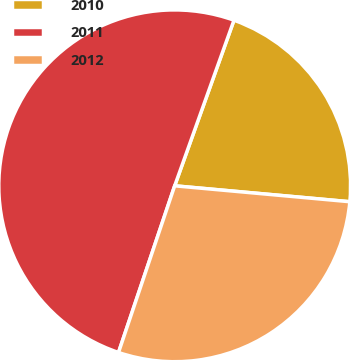Convert chart. <chart><loc_0><loc_0><loc_500><loc_500><pie_chart><fcel>2010<fcel>2011<fcel>2012<nl><fcel>20.97%<fcel>50.3%<fcel>28.73%<nl></chart> 